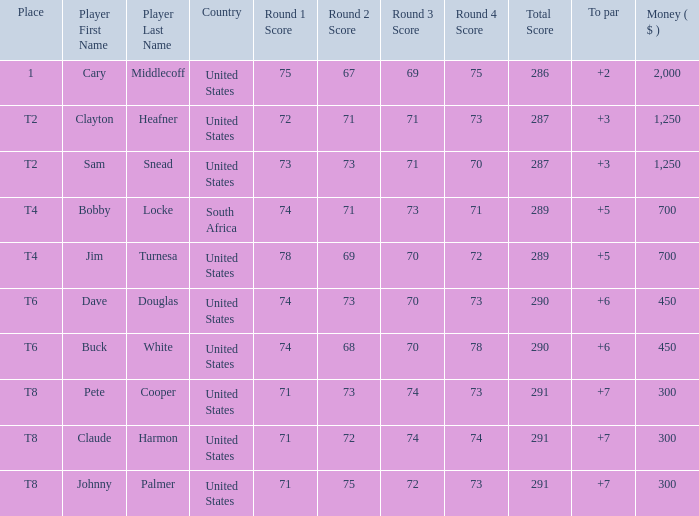What Country is Player Sam Snead with a To par of less than 5 from? United States. 